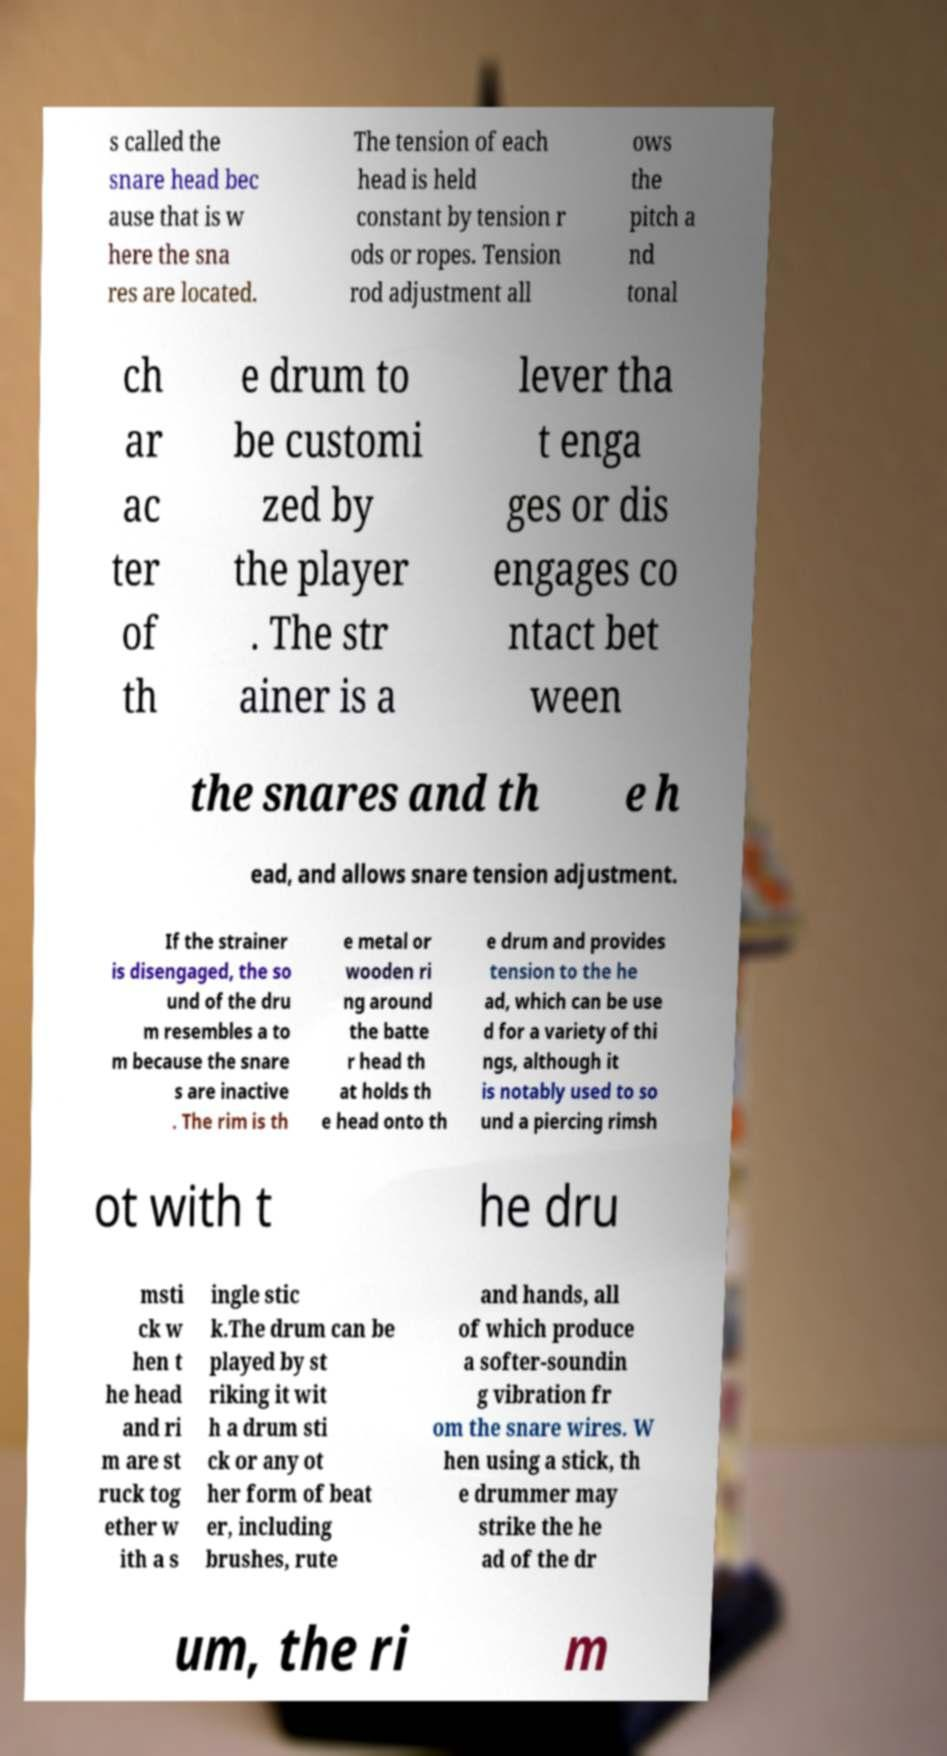Can you accurately transcribe the text from the provided image for me? s called the snare head bec ause that is w here the sna res are located. The tension of each head is held constant by tension r ods or ropes. Tension rod adjustment all ows the pitch a nd tonal ch ar ac ter of th e drum to be customi zed by the player . The str ainer is a lever tha t enga ges or dis engages co ntact bet ween the snares and th e h ead, and allows snare tension adjustment. If the strainer is disengaged, the so und of the dru m resembles a to m because the snare s are inactive . The rim is th e metal or wooden ri ng around the batte r head th at holds th e head onto th e drum and provides tension to the he ad, which can be use d for a variety of thi ngs, although it is notably used to so und a piercing rimsh ot with t he dru msti ck w hen t he head and ri m are st ruck tog ether w ith a s ingle stic k.The drum can be played by st riking it wit h a drum sti ck or any ot her form of beat er, including brushes, rute and hands, all of which produce a softer-soundin g vibration fr om the snare wires. W hen using a stick, th e drummer may strike the he ad of the dr um, the ri m 